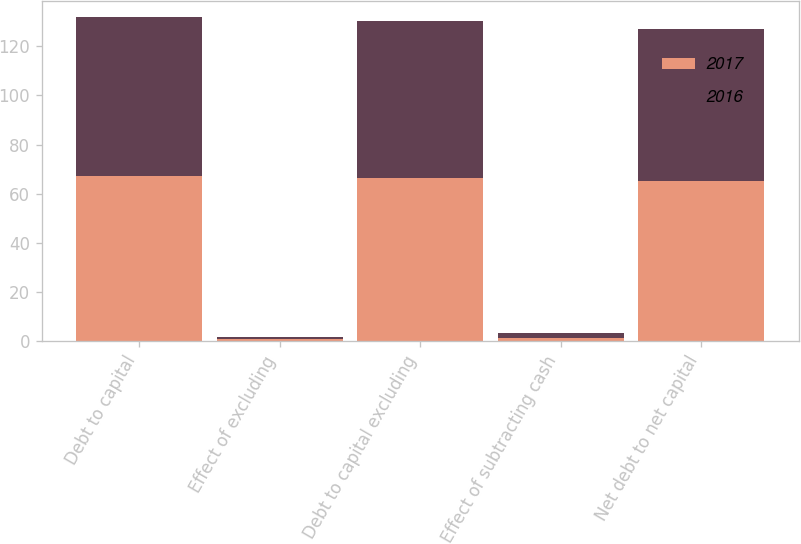<chart> <loc_0><loc_0><loc_500><loc_500><stacked_bar_chart><ecel><fcel>Debt to capital<fcel>Effect of excluding<fcel>Debt to capital excluding<fcel>Effect of subtracting cash<fcel>Net debt to net capital<nl><fcel>2017<fcel>67.1<fcel>0.8<fcel>66.3<fcel>1.1<fcel>65.2<nl><fcel>2016<fcel>64.8<fcel>1<fcel>63.8<fcel>2<fcel>61.8<nl></chart> 